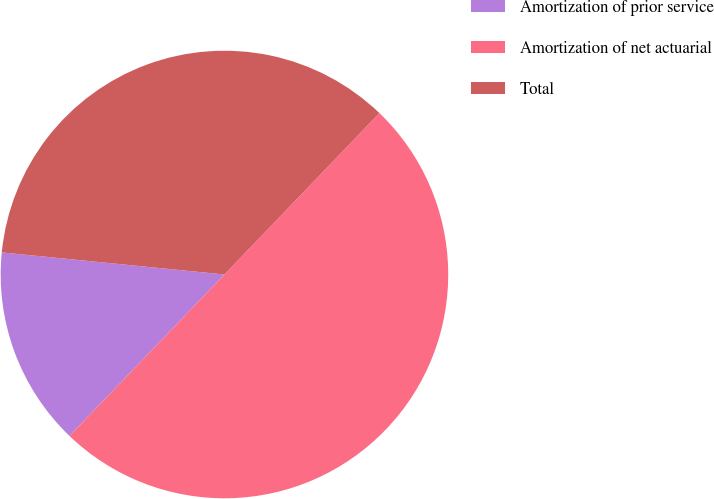Convert chart. <chart><loc_0><loc_0><loc_500><loc_500><pie_chart><fcel>Amortization of prior service<fcel>Amortization of net actuarial<fcel>Total<nl><fcel>14.4%<fcel>50.0%<fcel>35.6%<nl></chart> 